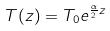<formula> <loc_0><loc_0><loc_500><loc_500>T ( z ) = T _ { 0 } e ^ { \frac { \alpha } { 2 } z }</formula> 